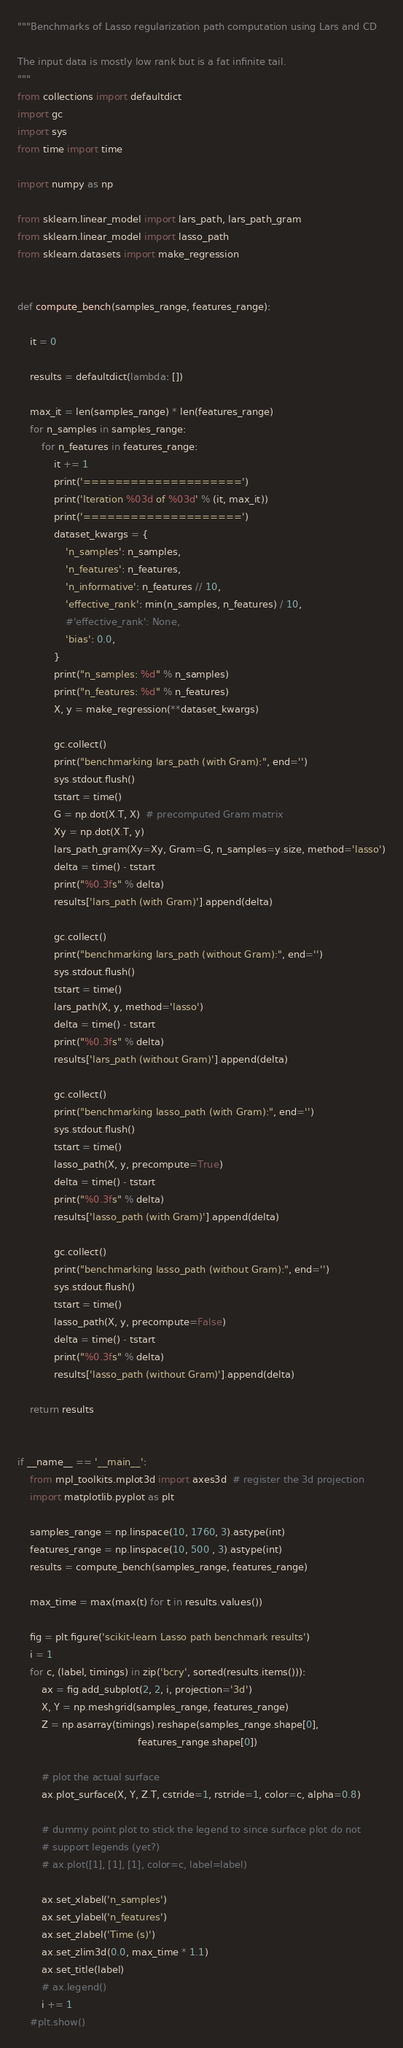Convert code to text. <code><loc_0><loc_0><loc_500><loc_500><_Python_>"""Benchmarks of Lasso regularization path computation using Lars and CD

The input data is mostly low rank but is a fat infinite tail.
"""
from collections import defaultdict
import gc
import sys
from time import time

import numpy as np

from sklearn.linear_model import lars_path, lars_path_gram
from sklearn.linear_model import lasso_path
from sklearn.datasets import make_regression


def compute_bench(samples_range, features_range):

    it = 0

    results = defaultdict(lambda: [])

    max_it = len(samples_range) * len(features_range)
    for n_samples in samples_range:
        for n_features in features_range:
            it += 1
            print('====================')
            print('Iteration %03d of %03d' % (it, max_it))
            print('====================')
            dataset_kwargs = {
                'n_samples': n_samples,
                'n_features': n_features,
                'n_informative': n_features // 10,
                'effective_rank': min(n_samples, n_features) / 10,
                #'effective_rank': None,
                'bias': 0.0,
            }
            print("n_samples: %d" % n_samples)
            print("n_features: %d" % n_features)
            X, y = make_regression(**dataset_kwargs)

            gc.collect()
            print("benchmarking lars_path (with Gram):", end='')
            sys.stdout.flush()
            tstart = time()
            G = np.dot(X.T, X)  # precomputed Gram matrix
            Xy = np.dot(X.T, y)
            lars_path_gram(Xy=Xy, Gram=G, n_samples=y.size, method='lasso')
            delta = time() - tstart
            print("%0.3fs" % delta)
            results['lars_path (with Gram)'].append(delta)

            gc.collect()
            print("benchmarking lars_path (without Gram):", end='')
            sys.stdout.flush()
            tstart = time()
            lars_path(X, y, method='lasso')
            delta = time() - tstart
            print("%0.3fs" % delta)
            results['lars_path (without Gram)'].append(delta)

            gc.collect()
            print("benchmarking lasso_path (with Gram):", end='')
            sys.stdout.flush()
            tstart = time()
            lasso_path(X, y, precompute=True)
            delta = time() - tstart
            print("%0.3fs" % delta)
            results['lasso_path (with Gram)'].append(delta)

            gc.collect()
            print("benchmarking lasso_path (without Gram):", end='')
            sys.stdout.flush()
            tstart = time()
            lasso_path(X, y, precompute=False)
            delta = time() - tstart
            print("%0.3fs" % delta)
            results['lasso_path (without Gram)'].append(delta)

    return results


if __name__ == '__main__':
    from mpl_toolkits.mplot3d import axes3d  # register the 3d projection
    import matplotlib.pyplot as plt

    samples_range = np.linspace(10, 1760, 3).astype(int) 
    features_range = np.linspace(10, 500 , 3).astype(int) 
    results = compute_bench(samples_range, features_range)

    max_time = max(max(t) for t in results.values())

    fig = plt.figure('scikit-learn Lasso path benchmark results')
    i = 1
    for c, (label, timings) in zip('bcry', sorted(results.items())):
        ax = fig.add_subplot(2, 2, i, projection='3d')
        X, Y = np.meshgrid(samples_range, features_range)
        Z = np.asarray(timings).reshape(samples_range.shape[0],
                                        features_range.shape[0])

        # plot the actual surface
        ax.plot_surface(X, Y, Z.T, cstride=1, rstride=1, color=c, alpha=0.8)

        # dummy point plot to stick the legend to since surface plot do not
        # support legends (yet?)
        # ax.plot([1], [1], [1], color=c, label=label)

        ax.set_xlabel('n_samples')
        ax.set_ylabel('n_features')
        ax.set_zlabel('Time (s)')
        ax.set_zlim3d(0.0, max_time * 1.1)
        ax.set_title(label)
        # ax.legend()
        i += 1
    #plt.show()
</code> 